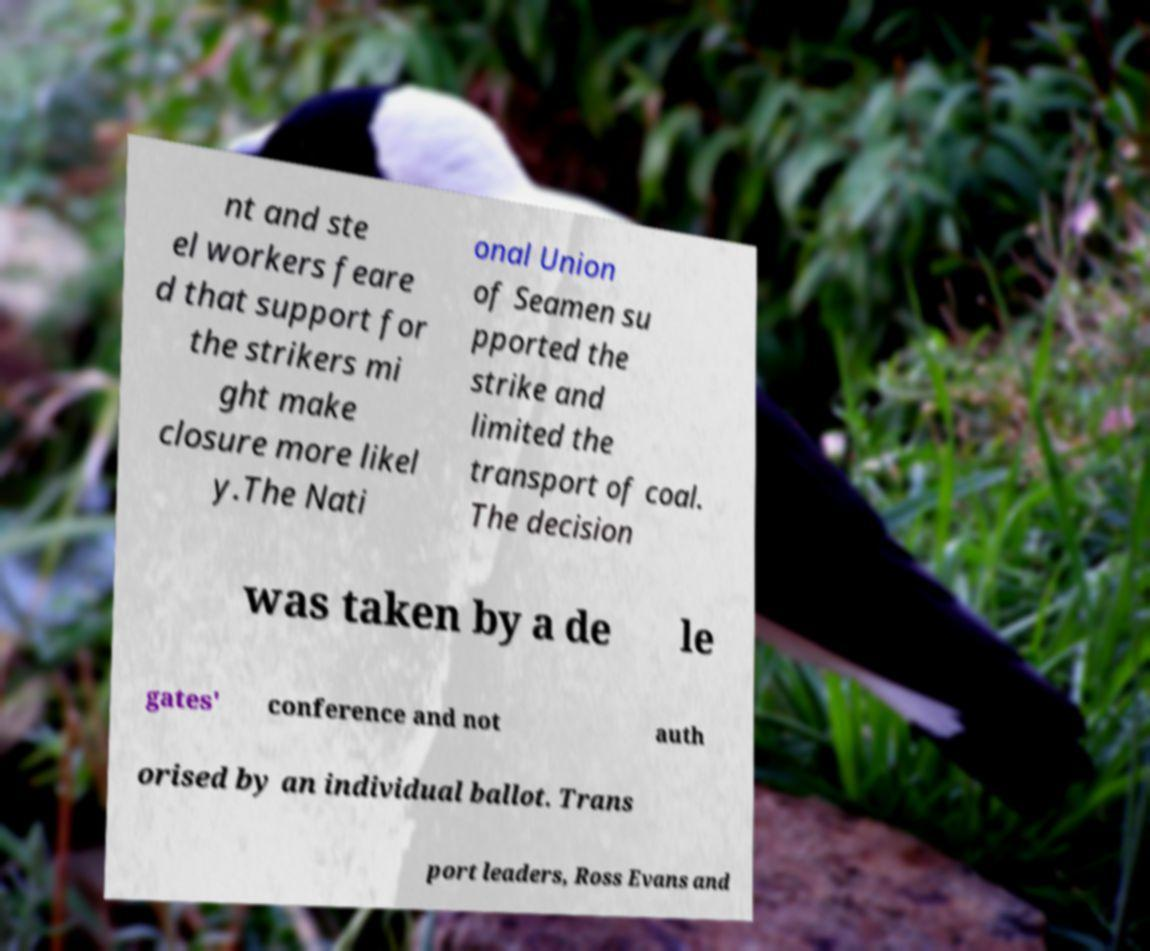Can you read and provide the text displayed in the image?This photo seems to have some interesting text. Can you extract and type it out for me? nt and ste el workers feare d that support for the strikers mi ght make closure more likel y.The Nati onal Union of Seamen su pported the strike and limited the transport of coal. The decision was taken by a de le gates' conference and not auth orised by an individual ballot. Trans port leaders, Ross Evans and 